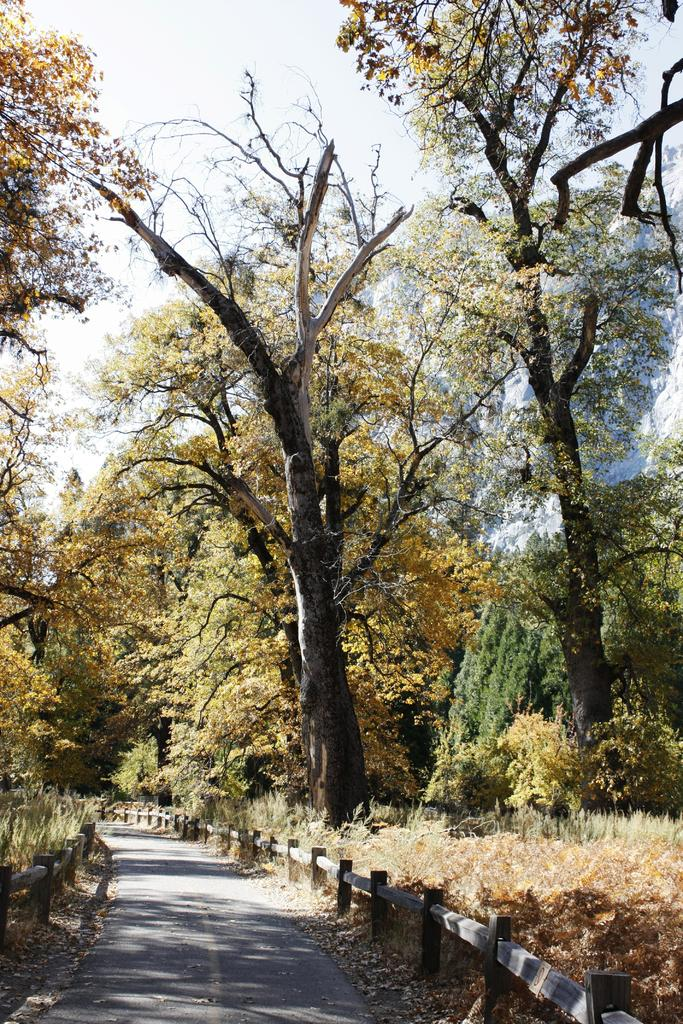What is located at the bottom of the image? There is a road at the bottom of the image. What can be seen alongside the road in the image? There are fences in the image. What type of vegetation is visible in the background of the image? There are trees in the background of the image. What else is visible in the background of the image? The sky is visible in the background of the image. What type of ground cover is on the right side of the image? There is grass on the right side of the image. What type of sugar is being used to sweeten the dinner with a friend in the image? There is no dinner or friend present in the image, and therefore no sugar or sweetening is taking place. 